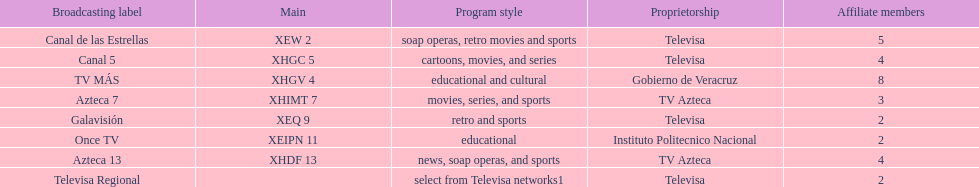Which owner has the most networks? Televisa. 